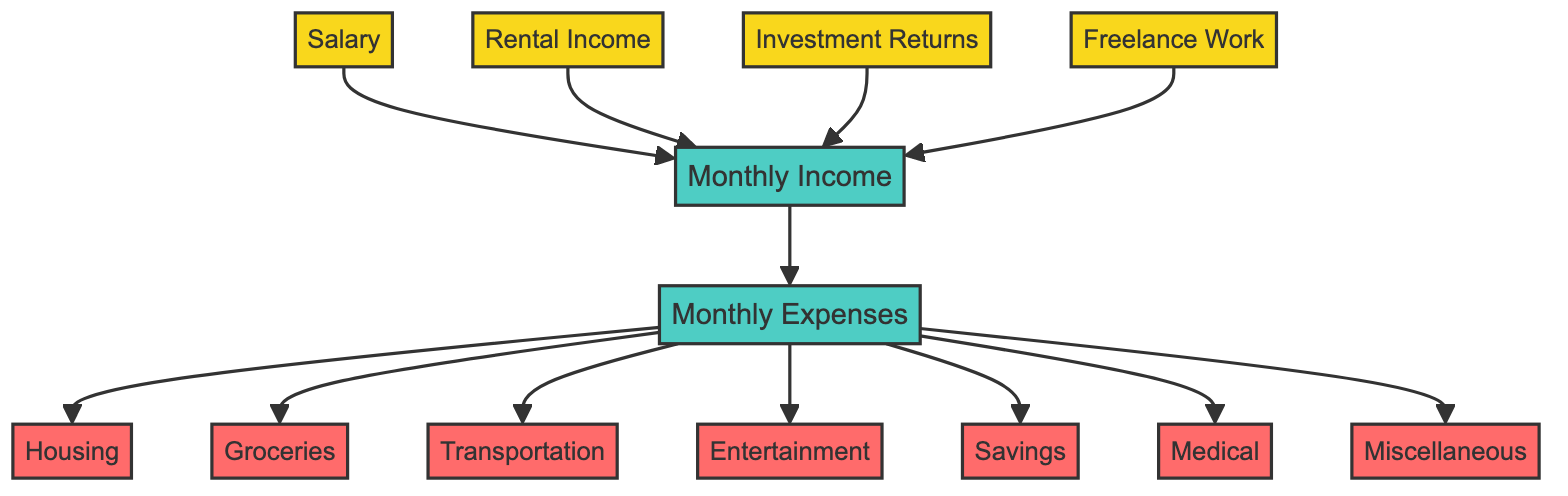What are the income sources listed in the diagram? The diagram includes four nodes under income sources: Salary, Rental Income, Investment Returns, and Freelance Work.
Answer: Four How many expense categories are represented? The expense categories represented in the diagram are Housing, Groceries, Transportation, Entertainment, Savings, Medical, and Miscellaneous, which totals to seven categories.
Answer: Seven What is the relationship between 'Income' and 'Expenses'? The diagram shows that 'Income' is the source that feeds into 'Expenses', indicating that monthly income influences monthly expenses.
Answer: Feeds into What is the first income source mentioned? The first income source listed in the diagram is 'Salary', which refers to the monthly paycheck from a job.
Answer: Salary Which expense category encompasses rent or mortgage payments? The expense category that encompasses rent or mortgage payments is 'Housing', which includes utilities and property taxes as well.
Answer: Housing How many types of income are directly linked to 'Income'? There are four types of income linked to 'Income': Salary, Rental Income, Investment Returns, and Freelance Work.
Answer: Four Identify the category that includes concert tickets and music albums. The expense category that includes concert tickets, movies, streaming services, and music albums is 'Entertainment'.
Answer: Entertainment What is the last expense category listed in the flow? The last expense category listed in the diagram is 'Miscellaneous', which refers to clothing, personal care, gifts, and donations.
Answer: Miscellaneous How do the nodes 'Income' and 'Expenses' connect in the diagram? The nodes 'Income' and 'Expenses' are connected in a direct flow, indicating that income is used to cover expenses.
Answer: Direct flow 